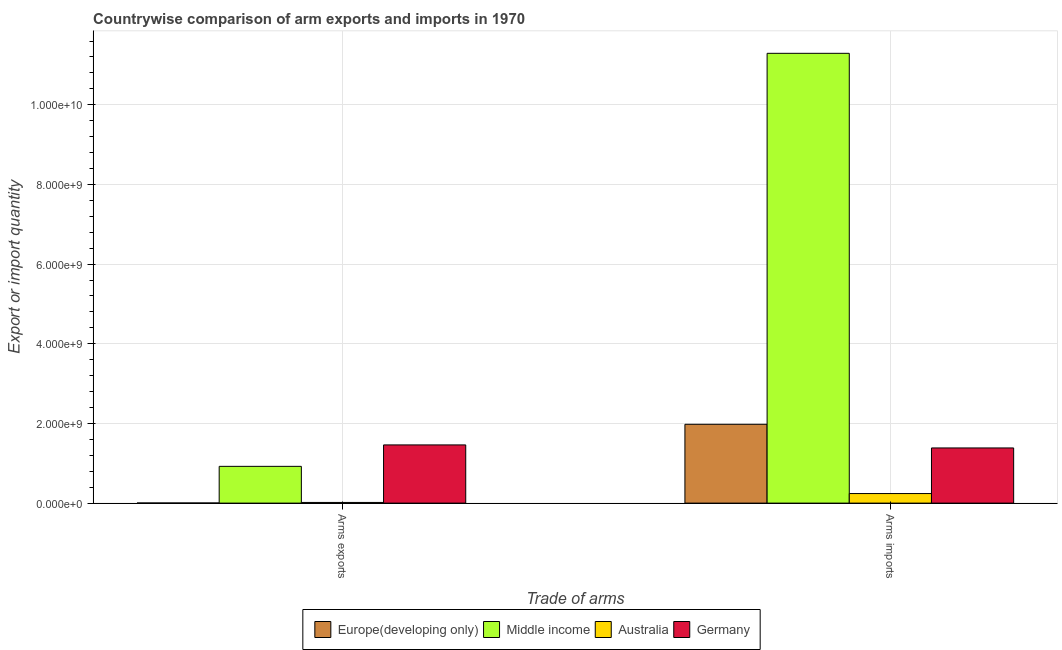How many different coloured bars are there?
Give a very brief answer. 4. How many groups of bars are there?
Make the answer very short. 2. Are the number of bars on each tick of the X-axis equal?
Your response must be concise. Yes. How many bars are there on the 1st tick from the left?
Make the answer very short. 4. How many bars are there on the 2nd tick from the right?
Ensure brevity in your answer.  4. What is the label of the 1st group of bars from the left?
Make the answer very short. Arms exports. What is the arms exports in Middle income?
Offer a terse response. 9.23e+08. Across all countries, what is the maximum arms exports?
Your answer should be very brief. 1.46e+09. Across all countries, what is the minimum arms exports?
Offer a very short reply. 3.00e+06. In which country was the arms exports maximum?
Make the answer very short. Germany. In which country was the arms exports minimum?
Offer a terse response. Europe(developing only). What is the total arms imports in the graph?
Make the answer very short. 1.49e+1. What is the difference between the arms imports in Australia and that in Middle income?
Your answer should be compact. -1.11e+1. What is the difference between the arms imports in Europe(developing only) and the arms exports in Germany?
Keep it short and to the point. 5.18e+08. What is the average arms imports per country?
Give a very brief answer. 3.72e+09. What is the difference between the arms imports and arms exports in Australia?
Offer a very short reply. 2.23e+08. In how many countries, is the arms exports greater than 10400000000 ?
Your response must be concise. 0. What is the ratio of the arms imports in Middle income to that in Europe(developing only)?
Your answer should be compact. 5.71. In how many countries, is the arms exports greater than the average arms exports taken over all countries?
Provide a short and direct response. 2. What does the 2nd bar from the right in Arms imports represents?
Provide a short and direct response. Australia. How many bars are there?
Provide a succinct answer. 8. What is the difference between two consecutive major ticks on the Y-axis?
Provide a succinct answer. 2.00e+09. What is the title of the graph?
Make the answer very short. Countrywise comparison of arm exports and imports in 1970. Does "Netherlands" appear as one of the legend labels in the graph?
Offer a terse response. No. What is the label or title of the X-axis?
Your answer should be very brief. Trade of arms. What is the label or title of the Y-axis?
Your answer should be compact. Export or import quantity. What is the Export or import quantity in Europe(developing only) in Arms exports?
Your response must be concise. 3.00e+06. What is the Export or import quantity in Middle income in Arms exports?
Offer a very short reply. 9.23e+08. What is the Export or import quantity of Australia in Arms exports?
Ensure brevity in your answer.  1.70e+07. What is the Export or import quantity of Germany in Arms exports?
Make the answer very short. 1.46e+09. What is the Export or import quantity in Europe(developing only) in Arms imports?
Make the answer very short. 1.98e+09. What is the Export or import quantity of Middle income in Arms imports?
Ensure brevity in your answer.  1.13e+1. What is the Export or import quantity of Australia in Arms imports?
Offer a very short reply. 2.40e+08. What is the Export or import quantity in Germany in Arms imports?
Give a very brief answer. 1.38e+09. Across all Trade of arms, what is the maximum Export or import quantity of Europe(developing only)?
Offer a very short reply. 1.98e+09. Across all Trade of arms, what is the maximum Export or import quantity in Middle income?
Provide a succinct answer. 1.13e+1. Across all Trade of arms, what is the maximum Export or import quantity of Australia?
Provide a succinct answer. 2.40e+08. Across all Trade of arms, what is the maximum Export or import quantity of Germany?
Give a very brief answer. 1.46e+09. Across all Trade of arms, what is the minimum Export or import quantity of Europe(developing only)?
Keep it short and to the point. 3.00e+06. Across all Trade of arms, what is the minimum Export or import quantity in Middle income?
Give a very brief answer. 9.23e+08. Across all Trade of arms, what is the minimum Export or import quantity of Australia?
Offer a very short reply. 1.70e+07. Across all Trade of arms, what is the minimum Export or import quantity of Germany?
Ensure brevity in your answer.  1.38e+09. What is the total Export or import quantity of Europe(developing only) in the graph?
Your response must be concise. 1.98e+09. What is the total Export or import quantity of Middle income in the graph?
Offer a very short reply. 1.22e+1. What is the total Export or import quantity in Australia in the graph?
Your answer should be compact. 2.57e+08. What is the total Export or import quantity in Germany in the graph?
Offer a terse response. 2.85e+09. What is the difference between the Export or import quantity of Europe(developing only) in Arms exports and that in Arms imports?
Provide a succinct answer. -1.98e+09. What is the difference between the Export or import quantity in Middle income in Arms exports and that in Arms imports?
Give a very brief answer. -1.04e+1. What is the difference between the Export or import quantity of Australia in Arms exports and that in Arms imports?
Your response must be concise. -2.23e+08. What is the difference between the Export or import quantity in Germany in Arms exports and that in Arms imports?
Ensure brevity in your answer.  7.60e+07. What is the difference between the Export or import quantity in Europe(developing only) in Arms exports and the Export or import quantity in Middle income in Arms imports?
Provide a short and direct response. -1.13e+1. What is the difference between the Export or import quantity in Europe(developing only) in Arms exports and the Export or import quantity in Australia in Arms imports?
Provide a short and direct response. -2.37e+08. What is the difference between the Export or import quantity of Europe(developing only) in Arms exports and the Export or import quantity of Germany in Arms imports?
Your response must be concise. -1.38e+09. What is the difference between the Export or import quantity of Middle income in Arms exports and the Export or import quantity of Australia in Arms imports?
Offer a very short reply. 6.83e+08. What is the difference between the Export or import quantity of Middle income in Arms exports and the Export or import quantity of Germany in Arms imports?
Your answer should be very brief. -4.62e+08. What is the difference between the Export or import quantity of Australia in Arms exports and the Export or import quantity of Germany in Arms imports?
Provide a short and direct response. -1.37e+09. What is the average Export or import quantity of Europe(developing only) per Trade of arms?
Offer a terse response. 9.91e+08. What is the average Export or import quantity of Middle income per Trade of arms?
Your answer should be very brief. 6.11e+09. What is the average Export or import quantity of Australia per Trade of arms?
Ensure brevity in your answer.  1.28e+08. What is the average Export or import quantity in Germany per Trade of arms?
Provide a short and direct response. 1.42e+09. What is the difference between the Export or import quantity in Europe(developing only) and Export or import quantity in Middle income in Arms exports?
Your answer should be very brief. -9.20e+08. What is the difference between the Export or import quantity in Europe(developing only) and Export or import quantity in Australia in Arms exports?
Offer a very short reply. -1.40e+07. What is the difference between the Export or import quantity of Europe(developing only) and Export or import quantity of Germany in Arms exports?
Provide a short and direct response. -1.46e+09. What is the difference between the Export or import quantity of Middle income and Export or import quantity of Australia in Arms exports?
Keep it short and to the point. 9.06e+08. What is the difference between the Export or import quantity in Middle income and Export or import quantity in Germany in Arms exports?
Your answer should be very brief. -5.38e+08. What is the difference between the Export or import quantity of Australia and Export or import quantity of Germany in Arms exports?
Provide a succinct answer. -1.44e+09. What is the difference between the Export or import quantity of Europe(developing only) and Export or import quantity of Middle income in Arms imports?
Your answer should be compact. -9.31e+09. What is the difference between the Export or import quantity of Europe(developing only) and Export or import quantity of Australia in Arms imports?
Your answer should be compact. 1.74e+09. What is the difference between the Export or import quantity in Europe(developing only) and Export or import quantity in Germany in Arms imports?
Provide a succinct answer. 5.94e+08. What is the difference between the Export or import quantity of Middle income and Export or import quantity of Australia in Arms imports?
Provide a short and direct response. 1.11e+1. What is the difference between the Export or import quantity in Middle income and Export or import quantity in Germany in Arms imports?
Offer a terse response. 9.91e+09. What is the difference between the Export or import quantity in Australia and Export or import quantity in Germany in Arms imports?
Ensure brevity in your answer.  -1.14e+09. What is the ratio of the Export or import quantity in Europe(developing only) in Arms exports to that in Arms imports?
Your response must be concise. 0. What is the ratio of the Export or import quantity of Middle income in Arms exports to that in Arms imports?
Your answer should be very brief. 0.08. What is the ratio of the Export or import quantity in Australia in Arms exports to that in Arms imports?
Your response must be concise. 0.07. What is the ratio of the Export or import quantity in Germany in Arms exports to that in Arms imports?
Offer a very short reply. 1.05. What is the difference between the highest and the second highest Export or import quantity of Europe(developing only)?
Make the answer very short. 1.98e+09. What is the difference between the highest and the second highest Export or import quantity in Middle income?
Give a very brief answer. 1.04e+1. What is the difference between the highest and the second highest Export or import quantity in Australia?
Provide a short and direct response. 2.23e+08. What is the difference between the highest and the second highest Export or import quantity in Germany?
Give a very brief answer. 7.60e+07. What is the difference between the highest and the lowest Export or import quantity of Europe(developing only)?
Provide a succinct answer. 1.98e+09. What is the difference between the highest and the lowest Export or import quantity in Middle income?
Make the answer very short. 1.04e+1. What is the difference between the highest and the lowest Export or import quantity of Australia?
Your response must be concise. 2.23e+08. What is the difference between the highest and the lowest Export or import quantity in Germany?
Offer a very short reply. 7.60e+07. 